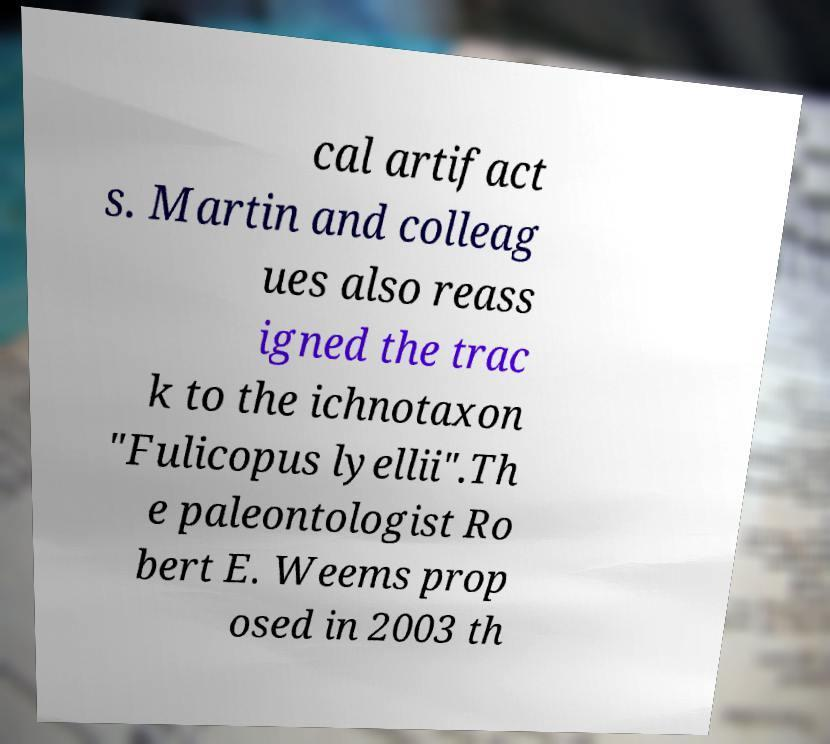I need the written content from this picture converted into text. Can you do that? cal artifact s. Martin and colleag ues also reass igned the trac k to the ichnotaxon "Fulicopus lyellii".Th e paleontologist Ro bert E. Weems prop osed in 2003 th 